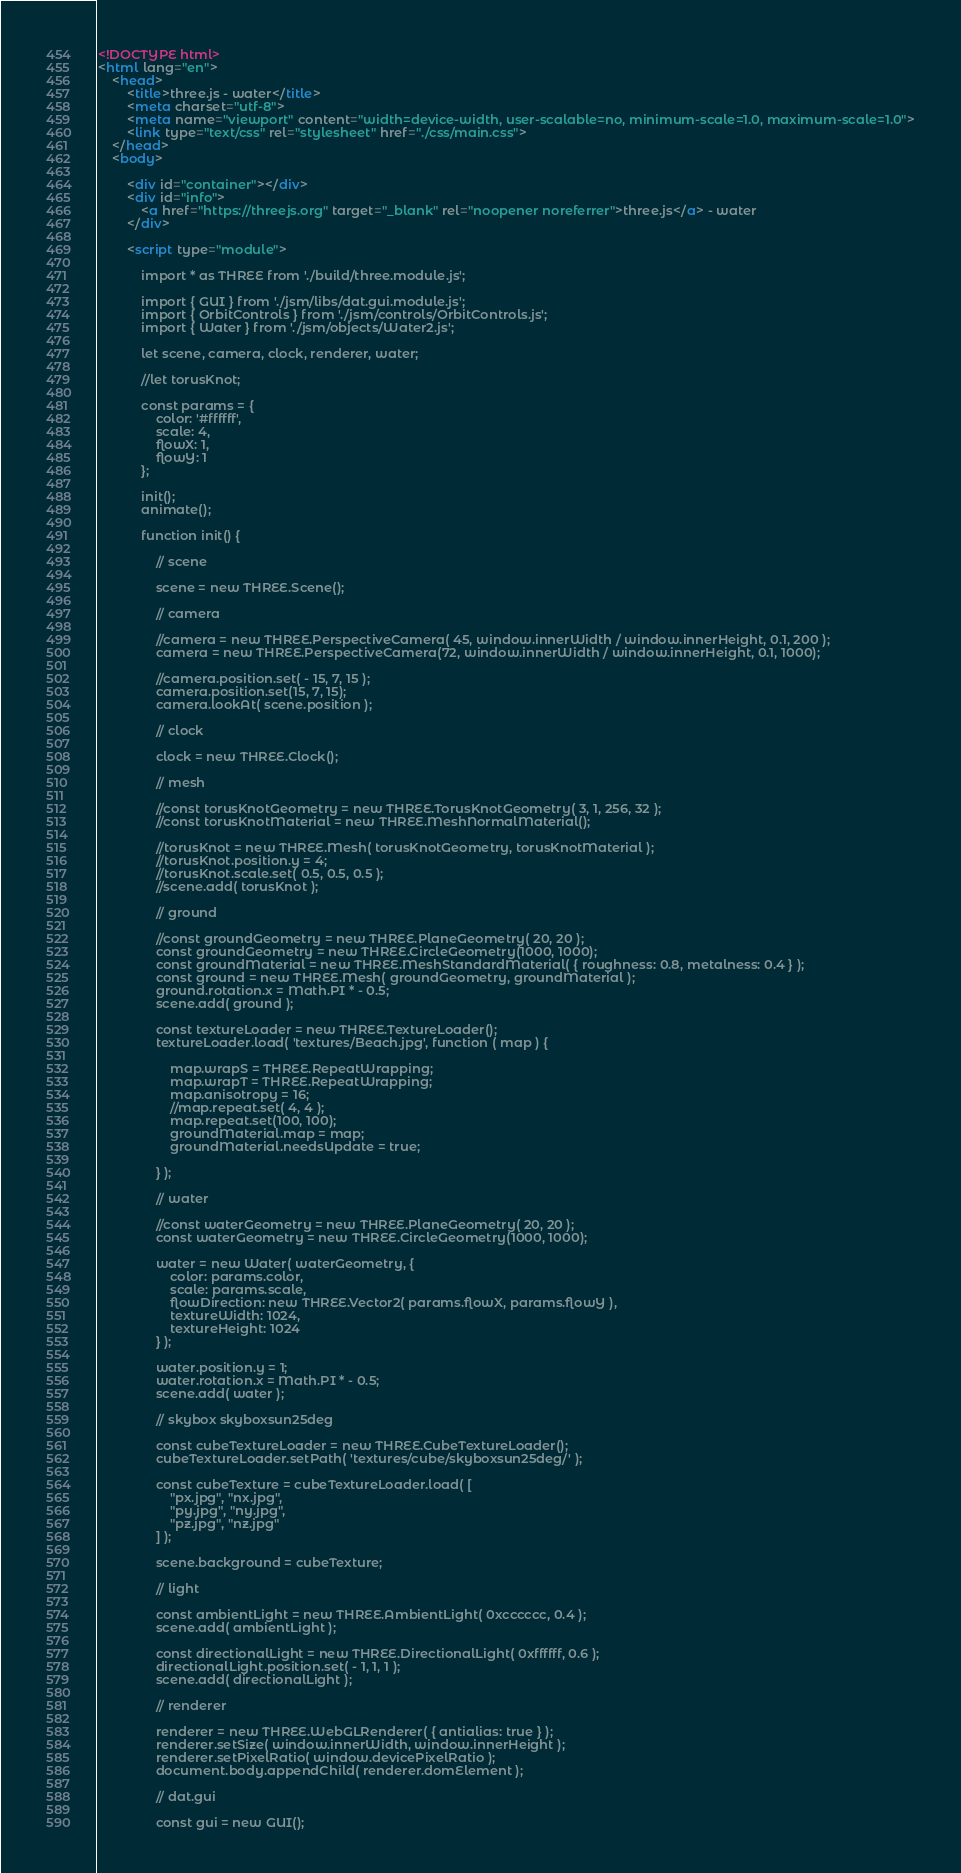Convert code to text. <code><loc_0><loc_0><loc_500><loc_500><_HTML_><!DOCTYPE html>
<html lang="en">
	<head>
		<title>three.js - water</title>
		<meta charset="utf-8">
		<meta name="viewport" content="width=device-width, user-scalable=no, minimum-scale=1.0, maximum-scale=1.0">
		<link type="text/css" rel="stylesheet" href="./css/main.css">
	</head>
	<body>

		<div id="container"></div>
		<div id="info">
			<a href="https://threejs.org" target="_blank" rel="noopener noreferrer">three.js</a> - water
		</div>

		<script type="module">

			import * as THREE from './build/three.module.js';

			import { GUI } from './jsm/libs/dat.gui.module.js';
			import { OrbitControls } from './jsm/controls/OrbitControls.js';
			import { Water } from './jsm/objects/Water2.js';

			let scene, camera, clock, renderer, water;

			//let torusKnot;

			const params = {
				color: '#ffffff',
				scale: 4,
				flowX: 1,
				flowY: 1
			};

			init();
			animate();

			function init() {

				// scene

				scene = new THREE.Scene();

				// camera

				//camera = new THREE.PerspectiveCamera( 45, window.innerWidth / window.innerHeight, 0.1, 200 );
                camera = new THREE.PerspectiveCamera(72, window.innerWidth / window.innerHeight, 0.1, 1000);

				//camera.position.set( - 15, 7, 15 );
                camera.position.set(15, 7, 15);
				camera.lookAt( scene.position );

				// clock

				clock = new THREE.Clock();

				// mesh

				//const torusKnotGeometry = new THREE.TorusKnotGeometry( 3, 1, 256, 32 );
				//const torusKnotMaterial = new THREE.MeshNormalMaterial();

				//torusKnot = new THREE.Mesh( torusKnotGeometry, torusKnotMaterial );
				//torusKnot.position.y = 4;
				//torusKnot.scale.set( 0.5, 0.5, 0.5 );
				//scene.add( torusKnot );

				// ground

				//const groundGeometry = new THREE.PlaneGeometry( 20, 20 );
                const groundGeometry = new THREE.CircleGeometry(1000, 1000);
				const groundMaterial = new THREE.MeshStandardMaterial( { roughness: 0.8, metalness: 0.4 } );
				const ground = new THREE.Mesh( groundGeometry, groundMaterial );
				ground.rotation.x = Math.PI * - 0.5;
				scene.add( ground );

				const textureLoader = new THREE.TextureLoader();
                textureLoader.load( 'textures/Beach.jpg', function ( map ) {

					map.wrapS = THREE.RepeatWrapping;
					map.wrapT = THREE.RepeatWrapping;
					map.anisotropy = 16;
					//map.repeat.set( 4, 4 );
                    map.repeat.set(100, 100);
					groundMaterial.map = map;
					groundMaterial.needsUpdate = true;

				} );

				// water

				//const waterGeometry = new THREE.PlaneGeometry( 20, 20 );
                const waterGeometry = new THREE.CircleGeometry(1000, 1000);

				water = new Water( waterGeometry, {
					color: params.color,
					scale: params.scale,
					flowDirection: new THREE.Vector2( params.flowX, params.flowY ),
					textureWidth: 1024,
					textureHeight: 1024
				} );

				water.position.y = 1;
				water.rotation.x = Math.PI * - 0.5;
				scene.add( water );

				// skybox skyboxsun25deg

				const cubeTextureLoader = new THREE.CubeTextureLoader();
                cubeTextureLoader.setPath( 'textures/cube/skyboxsun25deg/' );

				const cubeTexture = cubeTextureLoader.load( [
					"px.jpg", "nx.jpg",
					"py.jpg", "ny.jpg",
					"pz.jpg", "nz.jpg"
				] );

				scene.background = cubeTexture;

				// light

				const ambientLight = new THREE.AmbientLight( 0xcccccc, 0.4 );
				scene.add( ambientLight );

				const directionalLight = new THREE.DirectionalLight( 0xffffff, 0.6 );
				directionalLight.position.set( - 1, 1, 1 );
				scene.add( directionalLight );

				// renderer

				renderer = new THREE.WebGLRenderer( { antialias: true } );
				renderer.setSize( window.innerWidth, window.innerHeight );
				renderer.setPixelRatio( window.devicePixelRatio );
				document.body.appendChild( renderer.domElement );

				// dat.gui

				const gui = new GUI();
</code> 